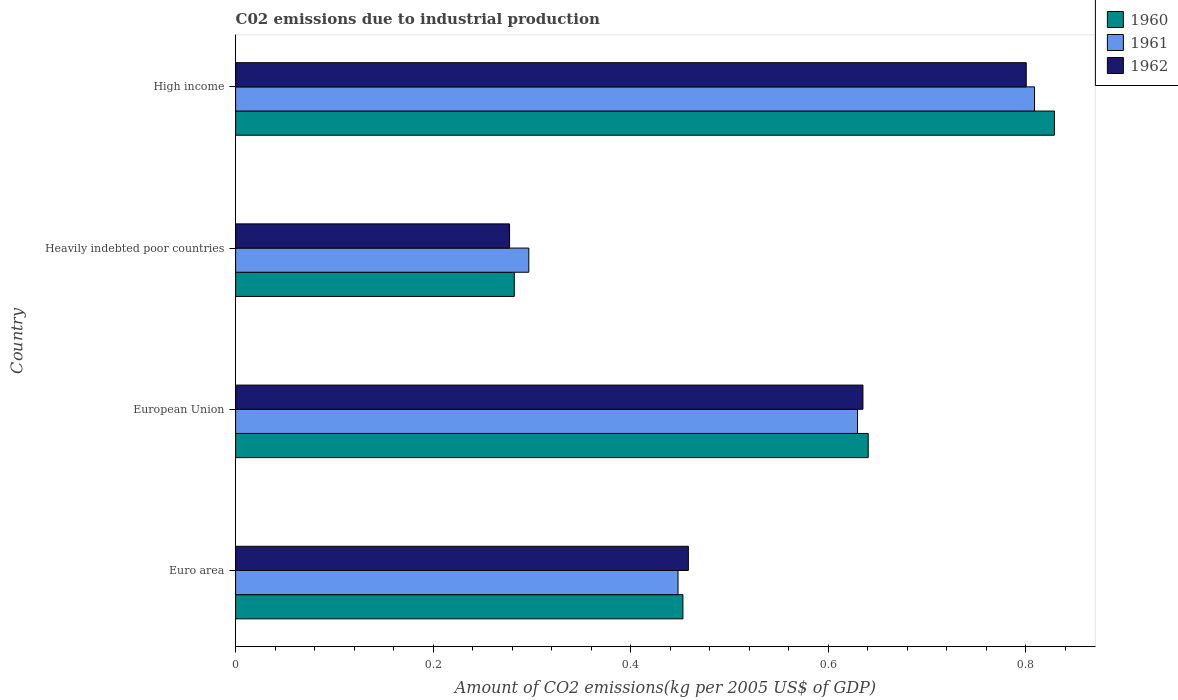How many different coloured bars are there?
Offer a very short reply. 3. Are the number of bars per tick equal to the number of legend labels?
Give a very brief answer. Yes. Are the number of bars on each tick of the Y-axis equal?
Provide a succinct answer. Yes. How many bars are there on the 1st tick from the top?
Offer a terse response. 3. How many bars are there on the 1st tick from the bottom?
Ensure brevity in your answer.  3. What is the label of the 3rd group of bars from the top?
Provide a succinct answer. European Union. What is the amount of CO2 emitted due to industrial production in 1962 in Heavily indebted poor countries?
Make the answer very short. 0.28. Across all countries, what is the maximum amount of CO2 emitted due to industrial production in 1961?
Provide a short and direct response. 0.81. Across all countries, what is the minimum amount of CO2 emitted due to industrial production in 1960?
Give a very brief answer. 0.28. In which country was the amount of CO2 emitted due to industrial production in 1960 maximum?
Your response must be concise. High income. In which country was the amount of CO2 emitted due to industrial production in 1962 minimum?
Give a very brief answer. Heavily indebted poor countries. What is the total amount of CO2 emitted due to industrial production in 1961 in the graph?
Offer a terse response. 2.18. What is the difference between the amount of CO2 emitted due to industrial production in 1961 in European Union and that in Heavily indebted poor countries?
Provide a succinct answer. 0.33. What is the difference between the amount of CO2 emitted due to industrial production in 1961 in Heavily indebted poor countries and the amount of CO2 emitted due to industrial production in 1960 in High income?
Keep it short and to the point. -0.53. What is the average amount of CO2 emitted due to industrial production in 1960 per country?
Give a very brief answer. 0.55. What is the difference between the amount of CO2 emitted due to industrial production in 1962 and amount of CO2 emitted due to industrial production in 1960 in High income?
Your response must be concise. -0.03. In how many countries, is the amount of CO2 emitted due to industrial production in 1962 greater than 0.2 kg?
Provide a succinct answer. 4. What is the ratio of the amount of CO2 emitted due to industrial production in 1961 in European Union to that in Heavily indebted poor countries?
Offer a terse response. 2.12. What is the difference between the highest and the second highest amount of CO2 emitted due to industrial production in 1961?
Your answer should be very brief. 0.18. What is the difference between the highest and the lowest amount of CO2 emitted due to industrial production in 1962?
Your response must be concise. 0.52. Is the sum of the amount of CO2 emitted due to industrial production in 1961 in Heavily indebted poor countries and High income greater than the maximum amount of CO2 emitted due to industrial production in 1962 across all countries?
Your answer should be compact. Yes. What does the 1st bar from the top in Euro area represents?
Your response must be concise. 1962. What does the 2nd bar from the bottom in Heavily indebted poor countries represents?
Your answer should be very brief. 1961. Are all the bars in the graph horizontal?
Make the answer very short. Yes. How many countries are there in the graph?
Ensure brevity in your answer.  4. What is the difference between two consecutive major ticks on the X-axis?
Keep it short and to the point. 0.2. Does the graph contain grids?
Your response must be concise. No. How many legend labels are there?
Make the answer very short. 3. What is the title of the graph?
Provide a succinct answer. C02 emissions due to industrial production. What is the label or title of the X-axis?
Offer a terse response. Amount of CO2 emissions(kg per 2005 US$ of GDP). What is the Amount of CO2 emissions(kg per 2005 US$ of GDP) in 1960 in Euro area?
Provide a succinct answer. 0.45. What is the Amount of CO2 emissions(kg per 2005 US$ of GDP) in 1961 in Euro area?
Offer a terse response. 0.45. What is the Amount of CO2 emissions(kg per 2005 US$ of GDP) in 1962 in Euro area?
Your response must be concise. 0.46. What is the Amount of CO2 emissions(kg per 2005 US$ of GDP) in 1960 in European Union?
Provide a short and direct response. 0.64. What is the Amount of CO2 emissions(kg per 2005 US$ of GDP) in 1961 in European Union?
Offer a very short reply. 0.63. What is the Amount of CO2 emissions(kg per 2005 US$ of GDP) in 1962 in European Union?
Your response must be concise. 0.64. What is the Amount of CO2 emissions(kg per 2005 US$ of GDP) of 1960 in Heavily indebted poor countries?
Provide a succinct answer. 0.28. What is the Amount of CO2 emissions(kg per 2005 US$ of GDP) of 1961 in Heavily indebted poor countries?
Your answer should be very brief. 0.3. What is the Amount of CO2 emissions(kg per 2005 US$ of GDP) of 1962 in Heavily indebted poor countries?
Offer a terse response. 0.28. What is the Amount of CO2 emissions(kg per 2005 US$ of GDP) of 1960 in High income?
Ensure brevity in your answer.  0.83. What is the Amount of CO2 emissions(kg per 2005 US$ of GDP) in 1961 in High income?
Offer a terse response. 0.81. What is the Amount of CO2 emissions(kg per 2005 US$ of GDP) of 1962 in High income?
Provide a succinct answer. 0.8. Across all countries, what is the maximum Amount of CO2 emissions(kg per 2005 US$ of GDP) of 1960?
Your response must be concise. 0.83. Across all countries, what is the maximum Amount of CO2 emissions(kg per 2005 US$ of GDP) of 1961?
Ensure brevity in your answer.  0.81. Across all countries, what is the maximum Amount of CO2 emissions(kg per 2005 US$ of GDP) in 1962?
Keep it short and to the point. 0.8. Across all countries, what is the minimum Amount of CO2 emissions(kg per 2005 US$ of GDP) of 1960?
Keep it short and to the point. 0.28. Across all countries, what is the minimum Amount of CO2 emissions(kg per 2005 US$ of GDP) of 1961?
Give a very brief answer. 0.3. Across all countries, what is the minimum Amount of CO2 emissions(kg per 2005 US$ of GDP) of 1962?
Provide a short and direct response. 0.28. What is the total Amount of CO2 emissions(kg per 2005 US$ of GDP) in 1960 in the graph?
Ensure brevity in your answer.  2.2. What is the total Amount of CO2 emissions(kg per 2005 US$ of GDP) of 1961 in the graph?
Ensure brevity in your answer.  2.18. What is the total Amount of CO2 emissions(kg per 2005 US$ of GDP) of 1962 in the graph?
Offer a very short reply. 2.17. What is the difference between the Amount of CO2 emissions(kg per 2005 US$ of GDP) in 1960 in Euro area and that in European Union?
Make the answer very short. -0.19. What is the difference between the Amount of CO2 emissions(kg per 2005 US$ of GDP) of 1961 in Euro area and that in European Union?
Offer a very short reply. -0.18. What is the difference between the Amount of CO2 emissions(kg per 2005 US$ of GDP) in 1962 in Euro area and that in European Union?
Your answer should be very brief. -0.18. What is the difference between the Amount of CO2 emissions(kg per 2005 US$ of GDP) in 1960 in Euro area and that in Heavily indebted poor countries?
Your answer should be compact. 0.17. What is the difference between the Amount of CO2 emissions(kg per 2005 US$ of GDP) in 1961 in Euro area and that in Heavily indebted poor countries?
Your answer should be very brief. 0.15. What is the difference between the Amount of CO2 emissions(kg per 2005 US$ of GDP) in 1962 in Euro area and that in Heavily indebted poor countries?
Your answer should be compact. 0.18. What is the difference between the Amount of CO2 emissions(kg per 2005 US$ of GDP) of 1960 in Euro area and that in High income?
Your response must be concise. -0.38. What is the difference between the Amount of CO2 emissions(kg per 2005 US$ of GDP) of 1961 in Euro area and that in High income?
Your answer should be very brief. -0.36. What is the difference between the Amount of CO2 emissions(kg per 2005 US$ of GDP) in 1962 in Euro area and that in High income?
Give a very brief answer. -0.34. What is the difference between the Amount of CO2 emissions(kg per 2005 US$ of GDP) in 1960 in European Union and that in Heavily indebted poor countries?
Keep it short and to the point. 0.36. What is the difference between the Amount of CO2 emissions(kg per 2005 US$ of GDP) of 1961 in European Union and that in Heavily indebted poor countries?
Provide a succinct answer. 0.33. What is the difference between the Amount of CO2 emissions(kg per 2005 US$ of GDP) in 1962 in European Union and that in Heavily indebted poor countries?
Ensure brevity in your answer.  0.36. What is the difference between the Amount of CO2 emissions(kg per 2005 US$ of GDP) in 1960 in European Union and that in High income?
Make the answer very short. -0.19. What is the difference between the Amount of CO2 emissions(kg per 2005 US$ of GDP) of 1961 in European Union and that in High income?
Provide a succinct answer. -0.18. What is the difference between the Amount of CO2 emissions(kg per 2005 US$ of GDP) of 1962 in European Union and that in High income?
Your answer should be very brief. -0.17. What is the difference between the Amount of CO2 emissions(kg per 2005 US$ of GDP) in 1960 in Heavily indebted poor countries and that in High income?
Provide a succinct answer. -0.55. What is the difference between the Amount of CO2 emissions(kg per 2005 US$ of GDP) in 1961 in Heavily indebted poor countries and that in High income?
Offer a terse response. -0.51. What is the difference between the Amount of CO2 emissions(kg per 2005 US$ of GDP) of 1962 in Heavily indebted poor countries and that in High income?
Offer a terse response. -0.52. What is the difference between the Amount of CO2 emissions(kg per 2005 US$ of GDP) of 1960 in Euro area and the Amount of CO2 emissions(kg per 2005 US$ of GDP) of 1961 in European Union?
Your response must be concise. -0.18. What is the difference between the Amount of CO2 emissions(kg per 2005 US$ of GDP) of 1960 in Euro area and the Amount of CO2 emissions(kg per 2005 US$ of GDP) of 1962 in European Union?
Your response must be concise. -0.18. What is the difference between the Amount of CO2 emissions(kg per 2005 US$ of GDP) in 1961 in Euro area and the Amount of CO2 emissions(kg per 2005 US$ of GDP) in 1962 in European Union?
Make the answer very short. -0.19. What is the difference between the Amount of CO2 emissions(kg per 2005 US$ of GDP) in 1960 in Euro area and the Amount of CO2 emissions(kg per 2005 US$ of GDP) in 1961 in Heavily indebted poor countries?
Provide a short and direct response. 0.16. What is the difference between the Amount of CO2 emissions(kg per 2005 US$ of GDP) in 1960 in Euro area and the Amount of CO2 emissions(kg per 2005 US$ of GDP) in 1962 in Heavily indebted poor countries?
Your answer should be compact. 0.18. What is the difference between the Amount of CO2 emissions(kg per 2005 US$ of GDP) in 1961 in Euro area and the Amount of CO2 emissions(kg per 2005 US$ of GDP) in 1962 in Heavily indebted poor countries?
Provide a short and direct response. 0.17. What is the difference between the Amount of CO2 emissions(kg per 2005 US$ of GDP) of 1960 in Euro area and the Amount of CO2 emissions(kg per 2005 US$ of GDP) of 1961 in High income?
Make the answer very short. -0.36. What is the difference between the Amount of CO2 emissions(kg per 2005 US$ of GDP) in 1960 in Euro area and the Amount of CO2 emissions(kg per 2005 US$ of GDP) in 1962 in High income?
Offer a terse response. -0.35. What is the difference between the Amount of CO2 emissions(kg per 2005 US$ of GDP) of 1961 in Euro area and the Amount of CO2 emissions(kg per 2005 US$ of GDP) of 1962 in High income?
Offer a terse response. -0.35. What is the difference between the Amount of CO2 emissions(kg per 2005 US$ of GDP) of 1960 in European Union and the Amount of CO2 emissions(kg per 2005 US$ of GDP) of 1961 in Heavily indebted poor countries?
Your answer should be compact. 0.34. What is the difference between the Amount of CO2 emissions(kg per 2005 US$ of GDP) in 1960 in European Union and the Amount of CO2 emissions(kg per 2005 US$ of GDP) in 1962 in Heavily indebted poor countries?
Provide a succinct answer. 0.36. What is the difference between the Amount of CO2 emissions(kg per 2005 US$ of GDP) in 1961 in European Union and the Amount of CO2 emissions(kg per 2005 US$ of GDP) in 1962 in Heavily indebted poor countries?
Provide a succinct answer. 0.35. What is the difference between the Amount of CO2 emissions(kg per 2005 US$ of GDP) of 1960 in European Union and the Amount of CO2 emissions(kg per 2005 US$ of GDP) of 1961 in High income?
Ensure brevity in your answer.  -0.17. What is the difference between the Amount of CO2 emissions(kg per 2005 US$ of GDP) of 1960 in European Union and the Amount of CO2 emissions(kg per 2005 US$ of GDP) of 1962 in High income?
Your response must be concise. -0.16. What is the difference between the Amount of CO2 emissions(kg per 2005 US$ of GDP) in 1961 in European Union and the Amount of CO2 emissions(kg per 2005 US$ of GDP) in 1962 in High income?
Ensure brevity in your answer.  -0.17. What is the difference between the Amount of CO2 emissions(kg per 2005 US$ of GDP) of 1960 in Heavily indebted poor countries and the Amount of CO2 emissions(kg per 2005 US$ of GDP) of 1961 in High income?
Your answer should be compact. -0.53. What is the difference between the Amount of CO2 emissions(kg per 2005 US$ of GDP) of 1960 in Heavily indebted poor countries and the Amount of CO2 emissions(kg per 2005 US$ of GDP) of 1962 in High income?
Offer a terse response. -0.52. What is the difference between the Amount of CO2 emissions(kg per 2005 US$ of GDP) in 1961 in Heavily indebted poor countries and the Amount of CO2 emissions(kg per 2005 US$ of GDP) in 1962 in High income?
Your answer should be compact. -0.5. What is the average Amount of CO2 emissions(kg per 2005 US$ of GDP) of 1960 per country?
Make the answer very short. 0.55. What is the average Amount of CO2 emissions(kg per 2005 US$ of GDP) in 1961 per country?
Your answer should be compact. 0.55. What is the average Amount of CO2 emissions(kg per 2005 US$ of GDP) in 1962 per country?
Provide a short and direct response. 0.54. What is the difference between the Amount of CO2 emissions(kg per 2005 US$ of GDP) of 1960 and Amount of CO2 emissions(kg per 2005 US$ of GDP) of 1961 in Euro area?
Your answer should be very brief. 0. What is the difference between the Amount of CO2 emissions(kg per 2005 US$ of GDP) in 1960 and Amount of CO2 emissions(kg per 2005 US$ of GDP) in 1962 in Euro area?
Your response must be concise. -0.01. What is the difference between the Amount of CO2 emissions(kg per 2005 US$ of GDP) of 1961 and Amount of CO2 emissions(kg per 2005 US$ of GDP) of 1962 in Euro area?
Give a very brief answer. -0.01. What is the difference between the Amount of CO2 emissions(kg per 2005 US$ of GDP) in 1960 and Amount of CO2 emissions(kg per 2005 US$ of GDP) in 1961 in European Union?
Your answer should be compact. 0.01. What is the difference between the Amount of CO2 emissions(kg per 2005 US$ of GDP) of 1960 and Amount of CO2 emissions(kg per 2005 US$ of GDP) of 1962 in European Union?
Your answer should be compact. 0.01. What is the difference between the Amount of CO2 emissions(kg per 2005 US$ of GDP) of 1961 and Amount of CO2 emissions(kg per 2005 US$ of GDP) of 1962 in European Union?
Provide a succinct answer. -0.01. What is the difference between the Amount of CO2 emissions(kg per 2005 US$ of GDP) of 1960 and Amount of CO2 emissions(kg per 2005 US$ of GDP) of 1961 in Heavily indebted poor countries?
Provide a short and direct response. -0.01. What is the difference between the Amount of CO2 emissions(kg per 2005 US$ of GDP) of 1960 and Amount of CO2 emissions(kg per 2005 US$ of GDP) of 1962 in Heavily indebted poor countries?
Your answer should be compact. 0. What is the difference between the Amount of CO2 emissions(kg per 2005 US$ of GDP) of 1961 and Amount of CO2 emissions(kg per 2005 US$ of GDP) of 1962 in Heavily indebted poor countries?
Offer a terse response. 0.02. What is the difference between the Amount of CO2 emissions(kg per 2005 US$ of GDP) in 1960 and Amount of CO2 emissions(kg per 2005 US$ of GDP) in 1961 in High income?
Ensure brevity in your answer.  0.02. What is the difference between the Amount of CO2 emissions(kg per 2005 US$ of GDP) of 1960 and Amount of CO2 emissions(kg per 2005 US$ of GDP) of 1962 in High income?
Provide a succinct answer. 0.03. What is the difference between the Amount of CO2 emissions(kg per 2005 US$ of GDP) in 1961 and Amount of CO2 emissions(kg per 2005 US$ of GDP) in 1962 in High income?
Offer a very short reply. 0.01. What is the ratio of the Amount of CO2 emissions(kg per 2005 US$ of GDP) of 1960 in Euro area to that in European Union?
Offer a terse response. 0.71. What is the ratio of the Amount of CO2 emissions(kg per 2005 US$ of GDP) in 1961 in Euro area to that in European Union?
Offer a terse response. 0.71. What is the ratio of the Amount of CO2 emissions(kg per 2005 US$ of GDP) of 1962 in Euro area to that in European Union?
Ensure brevity in your answer.  0.72. What is the ratio of the Amount of CO2 emissions(kg per 2005 US$ of GDP) in 1960 in Euro area to that in Heavily indebted poor countries?
Offer a very short reply. 1.6. What is the ratio of the Amount of CO2 emissions(kg per 2005 US$ of GDP) in 1961 in Euro area to that in Heavily indebted poor countries?
Give a very brief answer. 1.51. What is the ratio of the Amount of CO2 emissions(kg per 2005 US$ of GDP) in 1962 in Euro area to that in Heavily indebted poor countries?
Provide a short and direct response. 1.65. What is the ratio of the Amount of CO2 emissions(kg per 2005 US$ of GDP) of 1960 in Euro area to that in High income?
Make the answer very short. 0.55. What is the ratio of the Amount of CO2 emissions(kg per 2005 US$ of GDP) in 1961 in Euro area to that in High income?
Your answer should be compact. 0.55. What is the ratio of the Amount of CO2 emissions(kg per 2005 US$ of GDP) in 1962 in Euro area to that in High income?
Provide a short and direct response. 0.57. What is the ratio of the Amount of CO2 emissions(kg per 2005 US$ of GDP) in 1960 in European Union to that in Heavily indebted poor countries?
Ensure brevity in your answer.  2.27. What is the ratio of the Amount of CO2 emissions(kg per 2005 US$ of GDP) in 1961 in European Union to that in Heavily indebted poor countries?
Give a very brief answer. 2.12. What is the ratio of the Amount of CO2 emissions(kg per 2005 US$ of GDP) in 1962 in European Union to that in Heavily indebted poor countries?
Offer a terse response. 2.29. What is the ratio of the Amount of CO2 emissions(kg per 2005 US$ of GDP) of 1960 in European Union to that in High income?
Offer a very short reply. 0.77. What is the ratio of the Amount of CO2 emissions(kg per 2005 US$ of GDP) of 1961 in European Union to that in High income?
Your response must be concise. 0.78. What is the ratio of the Amount of CO2 emissions(kg per 2005 US$ of GDP) of 1962 in European Union to that in High income?
Provide a succinct answer. 0.79. What is the ratio of the Amount of CO2 emissions(kg per 2005 US$ of GDP) in 1960 in Heavily indebted poor countries to that in High income?
Give a very brief answer. 0.34. What is the ratio of the Amount of CO2 emissions(kg per 2005 US$ of GDP) in 1961 in Heavily indebted poor countries to that in High income?
Offer a terse response. 0.37. What is the ratio of the Amount of CO2 emissions(kg per 2005 US$ of GDP) of 1962 in Heavily indebted poor countries to that in High income?
Offer a terse response. 0.35. What is the difference between the highest and the second highest Amount of CO2 emissions(kg per 2005 US$ of GDP) of 1960?
Offer a terse response. 0.19. What is the difference between the highest and the second highest Amount of CO2 emissions(kg per 2005 US$ of GDP) in 1961?
Provide a short and direct response. 0.18. What is the difference between the highest and the second highest Amount of CO2 emissions(kg per 2005 US$ of GDP) of 1962?
Your answer should be compact. 0.17. What is the difference between the highest and the lowest Amount of CO2 emissions(kg per 2005 US$ of GDP) of 1960?
Provide a short and direct response. 0.55. What is the difference between the highest and the lowest Amount of CO2 emissions(kg per 2005 US$ of GDP) of 1961?
Your response must be concise. 0.51. What is the difference between the highest and the lowest Amount of CO2 emissions(kg per 2005 US$ of GDP) of 1962?
Ensure brevity in your answer.  0.52. 